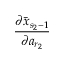<formula> <loc_0><loc_0><loc_500><loc_500>\frac { \partial \bar { x } _ { s _ { 2 } - 1 } } { \partial a _ { r _ { 2 } } }</formula> 